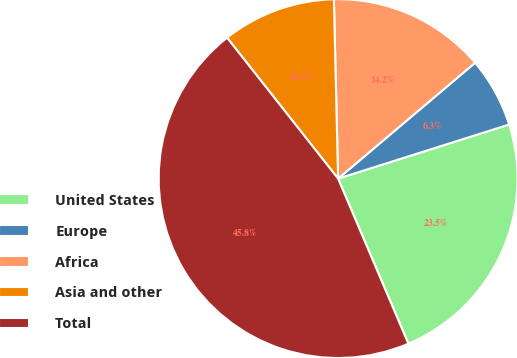Convert chart to OTSL. <chart><loc_0><loc_0><loc_500><loc_500><pie_chart><fcel>United States<fcel>Europe<fcel>Africa<fcel>Asia and other<fcel>Total<nl><fcel>23.47%<fcel>6.3%<fcel>14.2%<fcel>10.25%<fcel>45.79%<nl></chart> 